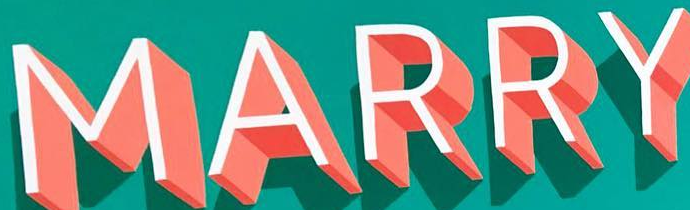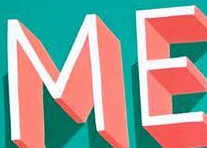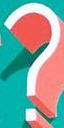Read the text from these images in sequence, separated by a semicolon. MARRY; ME; ? 